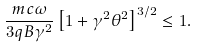Convert formula to latex. <formula><loc_0><loc_0><loc_500><loc_500>\frac { m c \omega } { 3 q B \gamma ^ { 2 } } \left [ 1 + \gamma ^ { 2 } \theta ^ { 2 } \right ] ^ { 3 / 2 } \leq 1 .</formula> 